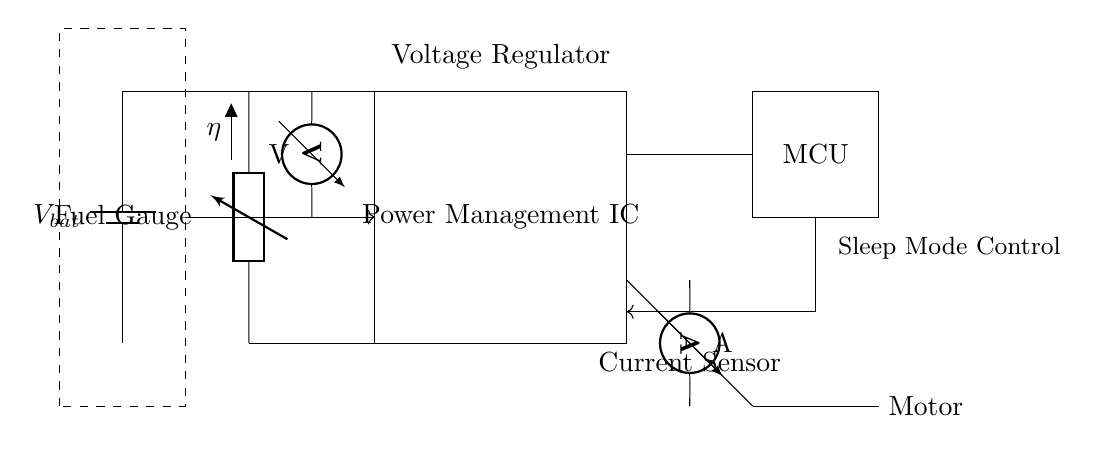What is the main component that manages power in this circuit? The main component responsible for managing power is the Power Management IC, which regulates and optimizes the distribution of power to various parts of the circuit.
Answer: Power Management IC What does the DC-DC converter do in this circuit? The DC-DC converter converts input voltage from the battery to a desired output voltage for efficient power usage, hence it directly influences energy output during operation.
Answer: Converts voltage What are the sensors used in this circuit? The circuit uses a voltmeter to measure voltage and an ammeter to measure current, allowing monitoring of electrical parameters for optimal battery management.
Answer: Voltmeter and ammeter How is the Fuel Gauge connected to the rest of the circuit? The Fuel Gauge is connected to the circuit through a dashed rectangle, indicating a monitoring role, and it provides output data to the Power Management IC for battery status assessment.
Answer: By a dashed rectangle What triggers the Sleep Mode Control in the circuit? The Sleep Mode Control is activated by the microcontroller, taking signal inputs regarding power usage and battery level, aiming to extend battery life during inactivity.
Answer: Microcontroller What is the purpose of the Load (Motor) in this circuit? The Load, specifically the motor, represents the component that consumes power, thereby demonstrating how the circuit delivers energy to perform work in portable construction tools.
Answer: To consume power What role does the voltage regulator play in optimizing battery life? The voltage regulator ensures that the output voltage remains stable and within required limits, reducing energy wastage and thus contributing to prolonging battery life through effective regulation.
Answer: Stabilizes output voltage 